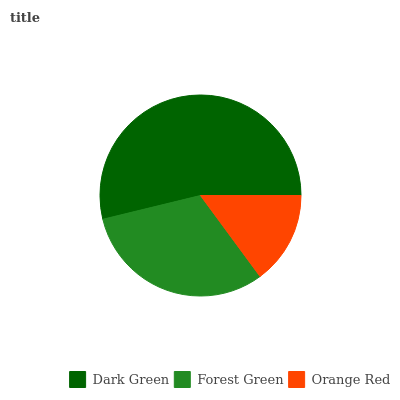Is Orange Red the minimum?
Answer yes or no. Yes. Is Dark Green the maximum?
Answer yes or no. Yes. Is Forest Green the minimum?
Answer yes or no. No. Is Forest Green the maximum?
Answer yes or no. No. Is Dark Green greater than Forest Green?
Answer yes or no. Yes. Is Forest Green less than Dark Green?
Answer yes or no. Yes. Is Forest Green greater than Dark Green?
Answer yes or no. No. Is Dark Green less than Forest Green?
Answer yes or no. No. Is Forest Green the high median?
Answer yes or no. Yes. Is Forest Green the low median?
Answer yes or no. Yes. Is Orange Red the high median?
Answer yes or no. No. Is Dark Green the low median?
Answer yes or no. No. 